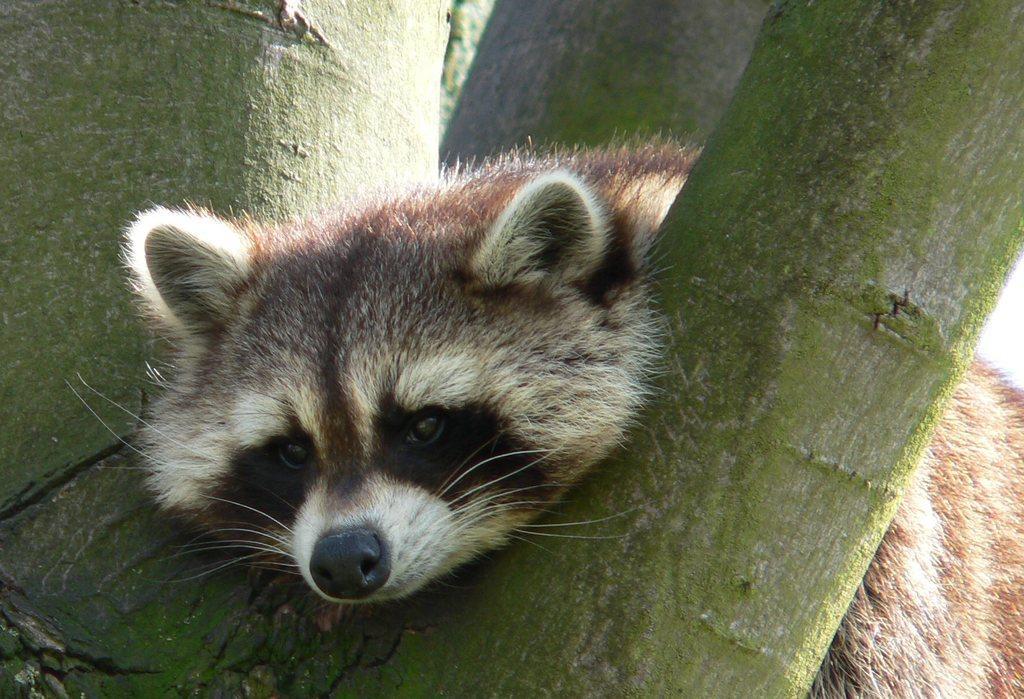Could you give a brief overview of what you see in this image? In this image we can see a raccoon lying on the tree branch. 